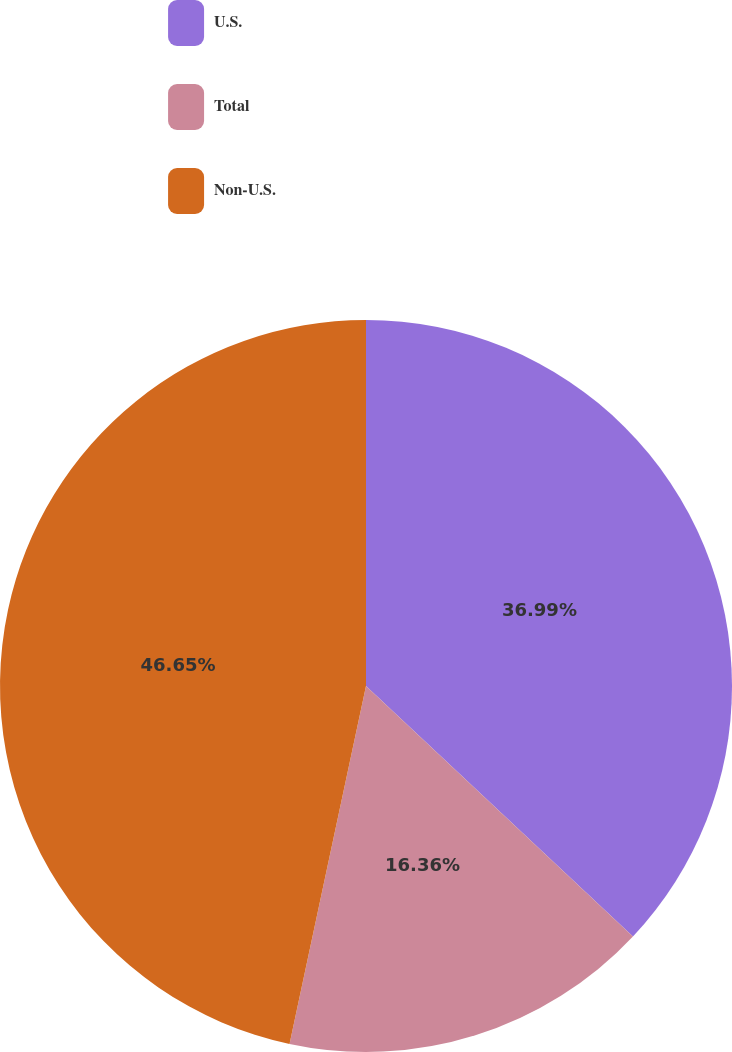Convert chart. <chart><loc_0><loc_0><loc_500><loc_500><pie_chart><fcel>U.S.<fcel>Total<fcel>Non-U.S.<nl><fcel>36.99%<fcel>16.36%<fcel>46.65%<nl></chart> 